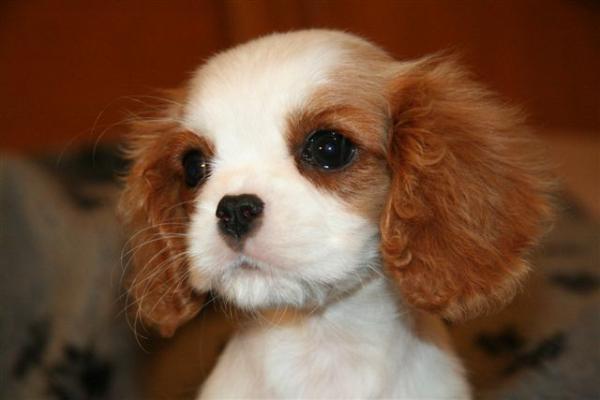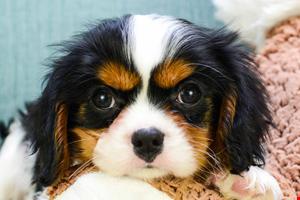The first image is the image on the left, the second image is the image on the right. For the images displayed, is the sentence "An image shows exactly two look-alike puppies." factually correct? Answer yes or no. No. 